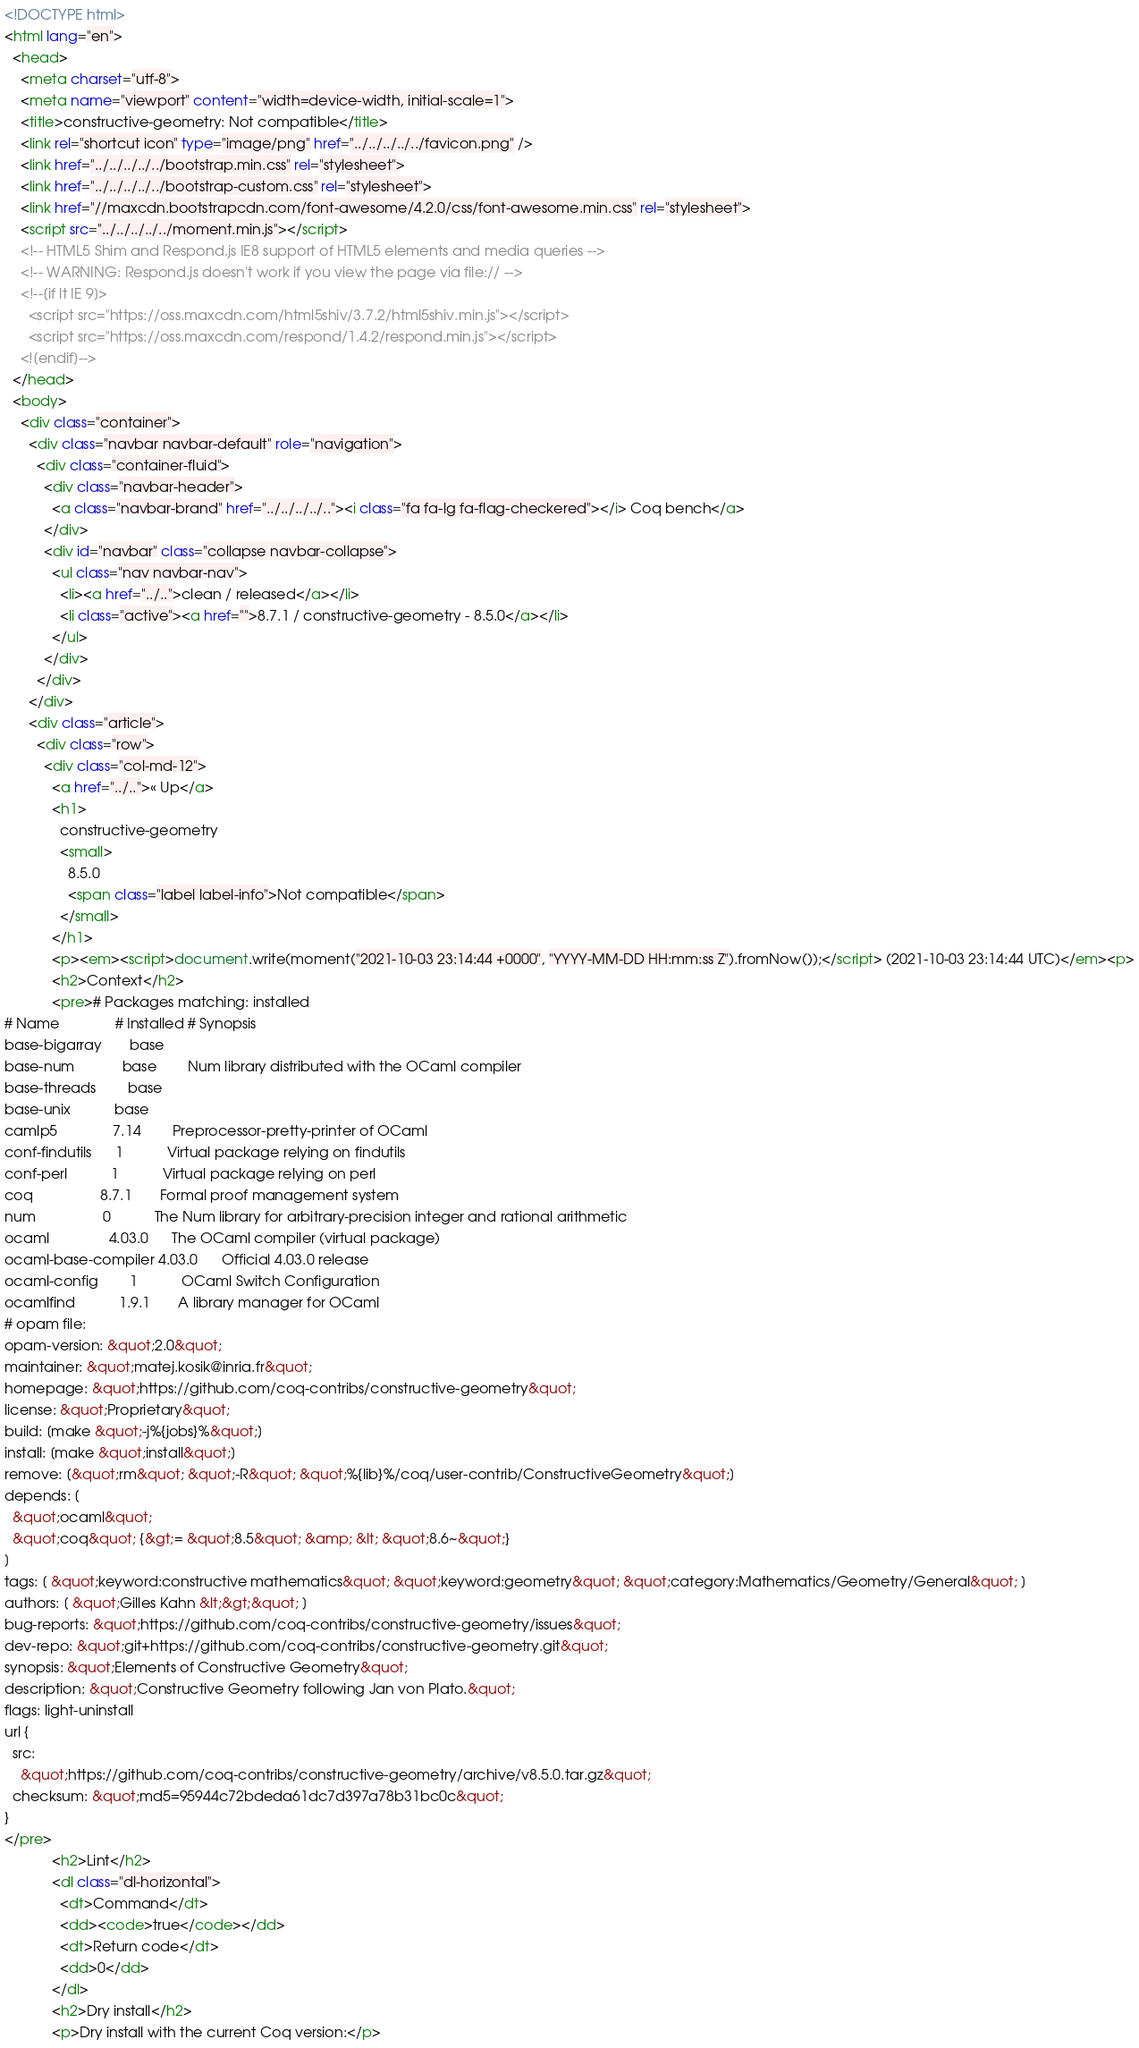<code> <loc_0><loc_0><loc_500><loc_500><_HTML_><!DOCTYPE html>
<html lang="en">
  <head>
    <meta charset="utf-8">
    <meta name="viewport" content="width=device-width, initial-scale=1">
    <title>constructive-geometry: Not compatible</title>
    <link rel="shortcut icon" type="image/png" href="../../../../../favicon.png" />
    <link href="../../../../../bootstrap.min.css" rel="stylesheet">
    <link href="../../../../../bootstrap-custom.css" rel="stylesheet">
    <link href="//maxcdn.bootstrapcdn.com/font-awesome/4.2.0/css/font-awesome.min.css" rel="stylesheet">
    <script src="../../../../../moment.min.js"></script>
    <!-- HTML5 Shim and Respond.js IE8 support of HTML5 elements and media queries -->
    <!-- WARNING: Respond.js doesn't work if you view the page via file:// -->
    <!--[if lt IE 9]>
      <script src="https://oss.maxcdn.com/html5shiv/3.7.2/html5shiv.min.js"></script>
      <script src="https://oss.maxcdn.com/respond/1.4.2/respond.min.js"></script>
    <![endif]-->
  </head>
  <body>
    <div class="container">
      <div class="navbar navbar-default" role="navigation">
        <div class="container-fluid">
          <div class="navbar-header">
            <a class="navbar-brand" href="../../../../.."><i class="fa fa-lg fa-flag-checkered"></i> Coq bench</a>
          </div>
          <div id="navbar" class="collapse navbar-collapse">
            <ul class="nav navbar-nav">
              <li><a href="../..">clean / released</a></li>
              <li class="active"><a href="">8.7.1 / constructive-geometry - 8.5.0</a></li>
            </ul>
          </div>
        </div>
      </div>
      <div class="article">
        <div class="row">
          <div class="col-md-12">
            <a href="../..">« Up</a>
            <h1>
              constructive-geometry
              <small>
                8.5.0
                <span class="label label-info">Not compatible</span>
              </small>
            </h1>
            <p><em><script>document.write(moment("2021-10-03 23:14:44 +0000", "YYYY-MM-DD HH:mm:ss Z").fromNow());</script> (2021-10-03 23:14:44 UTC)</em><p>
            <h2>Context</h2>
            <pre># Packages matching: installed
# Name              # Installed # Synopsis
base-bigarray       base
base-num            base        Num library distributed with the OCaml compiler
base-threads        base
base-unix           base
camlp5              7.14        Preprocessor-pretty-printer of OCaml
conf-findutils      1           Virtual package relying on findutils
conf-perl           1           Virtual package relying on perl
coq                 8.7.1       Formal proof management system
num                 0           The Num library for arbitrary-precision integer and rational arithmetic
ocaml               4.03.0      The OCaml compiler (virtual package)
ocaml-base-compiler 4.03.0      Official 4.03.0 release
ocaml-config        1           OCaml Switch Configuration
ocamlfind           1.9.1       A library manager for OCaml
# opam file:
opam-version: &quot;2.0&quot;
maintainer: &quot;matej.kosik@inria.fr&quot;
homepage: &quot;https://github.com/coq-contribs/constructive-geometry&quot;
license: &quot;Proprietary&quot;
build: [make &quot;-j%{jobs}%&quot;]
install: [make &quot;install&quot;]
remove: [&quot;rm&quot; &quot;-R&quot; &quot;%{lib}%/coq/user-contrib/ConstructiveGeometry&quot;]
depends: [
  &quot;ocaml&quot;
  &quot;coq&quot; {&gt;= &quot;8.5&quot; &amp; &lt; &quot;8.6~&quot;}
]
tags: [ &quot;keyword:constructive mathematics&quot; &quot;keyword:geometry&quot; &quot;category:Mathematics/Geometry/General&quot; ]
authors: [ &quot;Gilles Kahn &lt;&gt;&quot; ]
bug-reports: &quot;https://github.com/coq-contribs/constructive-geometry/issues&quot;
dev-repo: &quot;git+https://github.com/coq-contribs/constructive-geometry.git&quot;
synopsis: &quot;Elements of Constructive Geometry&quot;
description: &quot;Constructive Geometry following Jan von Plato.&quot;
flags: light-uninstall
url {
  src:
    &quot;https://github.com/coq-contribs/constructive-geometry/archive/v8.5.0.tar.gz&quot;
  checksum: &quot;md5=95944c72bdeda61dc7d397a78b31bc0c&quot;
}
</pre>
            <h2>Lint</h2>
            <dl class="dl-horizontal">
              <dt>Command</dt>
              <dd><code>true</code></dd>
              <dt>Return code</dt>
              <dd>0</dd>
            </dl>
            <h2>Dry install</h2>
            <p>Dry install with the current Coq version:</p></code> 